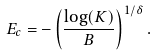<formula> <loc_0><loc_0><loc_500><loc_500>E _ { c } = - \left ( \frac { \log ( K ) } { B } \right ) ^ { 1 / \delta } .</formula> 